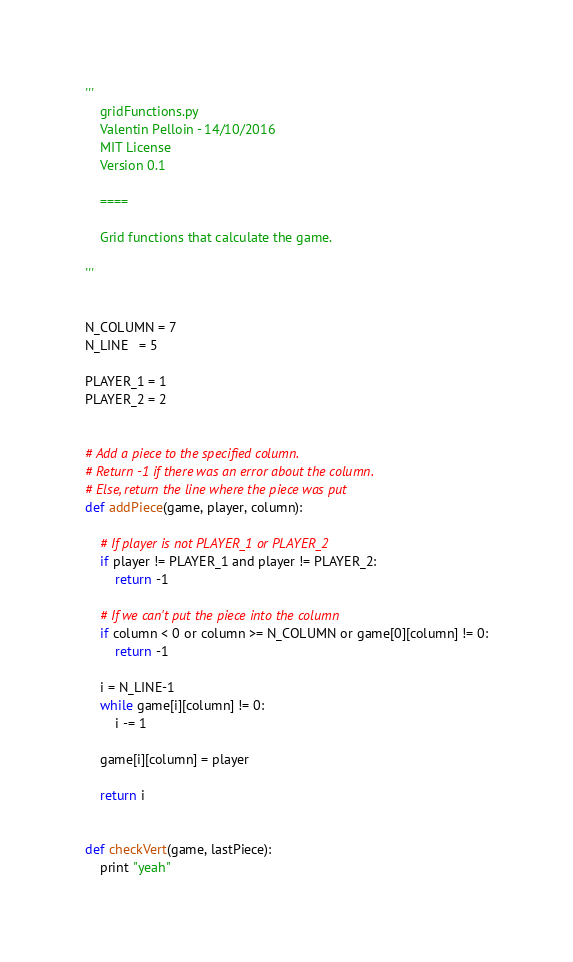Convert code to text. <code><loc_0><loc_0><loc_500><loc_500><_Python_>'''
    gridFunctions.py
    Valentin Pelloin - 14/10/2016
    MIT License
    Version 0.1

    ====

    Grid functions that calculate the game.

'''


N_COLUMN = 7
N_LINE   = 5

PLAYER_1 = 1
PLAYER_2 = 2


# Add a piece to the specified column.
# Return -1 if there was an error about the column.
# Else, return the line where the piece was put
def addPiece(game, player, column):

    # If player is not PLAYER_1 or PLAYER_2
    if player != PLAYER_1 and player != PLAYER_2:
        return -1

    # If we can't put the piece into the column
    if column < 0 or column >= N_COLUMN or game[0][column] != 0:
        return -1

    i = N_LINE-1
    while game[i][column] != 0:
        i -= 1

    game[i][column] = player

    return i


def checkVert(game, lastPiece):
    print "yeah"
</code> 